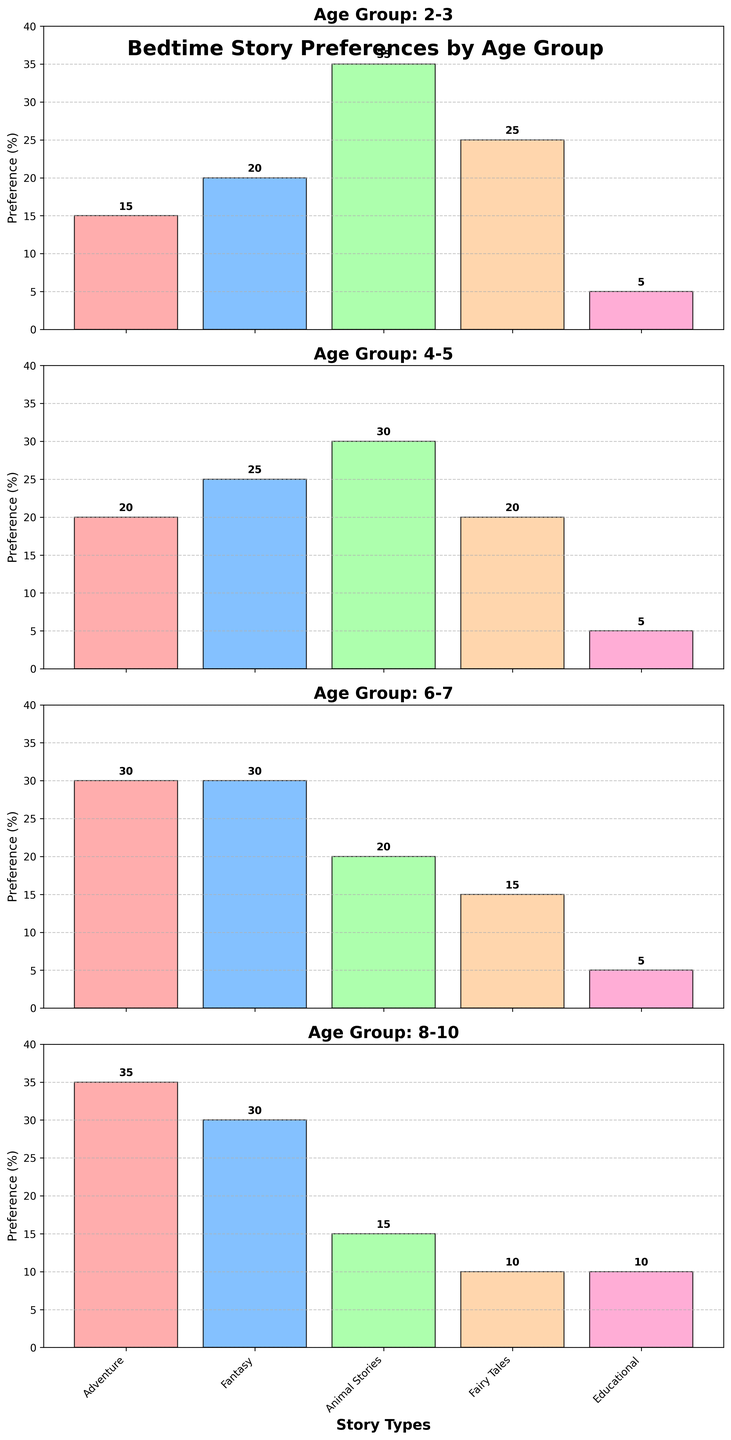What story type is most preferred by the 2-3 age group? In the first subplot, the bar graph for the 2-3 age group shows that "Animal Stories" has the highest bar. This indicates that "Animal Stories" is the most preferred story type for this age group.
Answer: Animal Stories Which age group has the least preference for Fairy Tales? By looking at all the subplots, we can compare the height of the bars for "Fairy Tales" across the different age groups. The 8-10 age group has the smallest bar for "Fairy Tales" indicating they have the least preference for it.
Answer: 8-10 Compare the preference for Adventure stories between the 6-7 and 8-10 age groups. Which age group has a higher preference? In the subplots for the 6-7 and 8-10 age groups, the bar for "Adventure" is taller for the 8-10 age group (35%) compared to the 6-7 age group (30%).
Answer: 8-10 What is the total preference percentage for Educational stories across all age groups? Add the values for Educational stories from all age groups: 5 (2-3) + 5 (4-5) + 5 (6-7) + 10 (8-10) = 25.
Answer: 25 Which age group shows an equal preference for Adventure and Fantasy stories? In the subplots, identify the age group where the bars for "Adventure" and "Fantasy" are of the same height. For the 6-7 age group, both bars representing "Adventure" and "Fantasy" are at 30%.
Answer: 6-7 How much more does the 2-3 age group prefer Animal Stories compared to Educational stories? Subtract the preference for Educational stories from the preference for Animal Stories in the 2-3 age group: 35% (Animal Stories) - 5% (Educational) = 30%.
Answer: 30 What is the average preference for Fairy Tales across all age groups? Add the values for Fairy Tales and divide by the number of age groups: (25 + 20 + 15 + 10) / 4 = 70 / 4 = 17.5.
Answer: 17.5 Which story type experiences a consistent decrease in preference as age increases? Observe the bars for each story type across the age groups and see which bars consistently decrease. "Fairy Tales" shows a consistent decrease from 25% to 10% as age increases.
Answer: Fairy Tales 